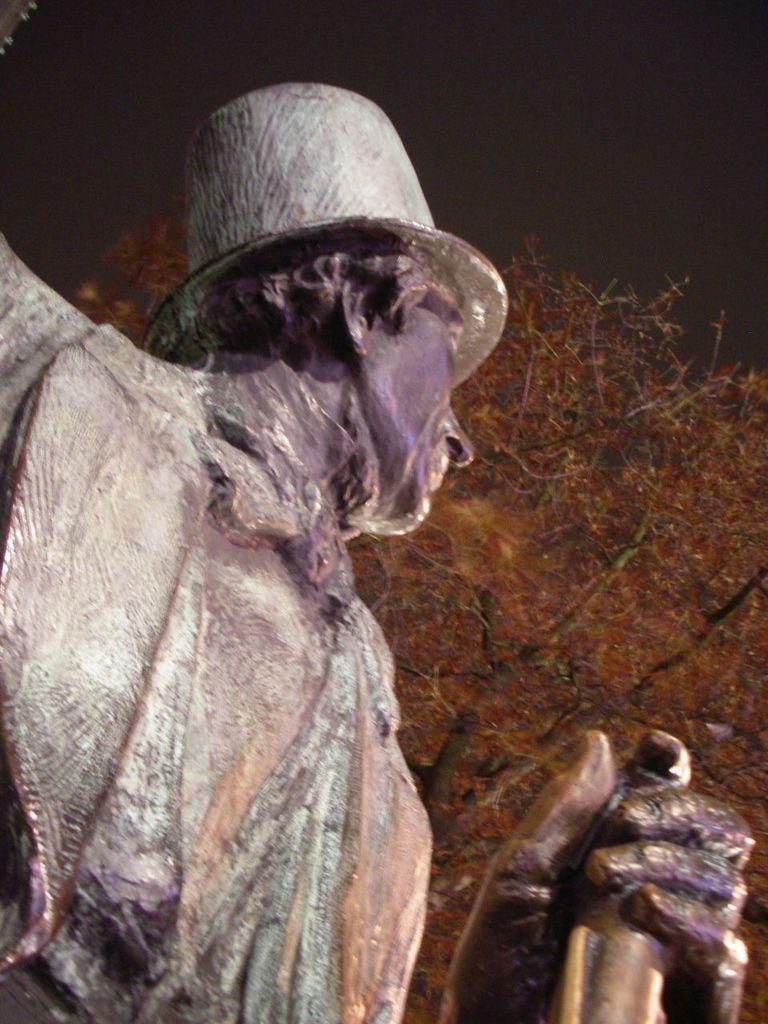What is the main subject of the image? There is a statue of a person in the image. What is the person in the statue holding? The person is holding an object in their hand. What can be seen in the background of the image? There is a tree in the background of the image. What type of food is the cook preparing in the image? There is no cook or food preparation visible in the image; it features a statue of a person holding an object. What emotion does the statue convey in the image? The statue is not expressing any emotions, as it is a static object. 